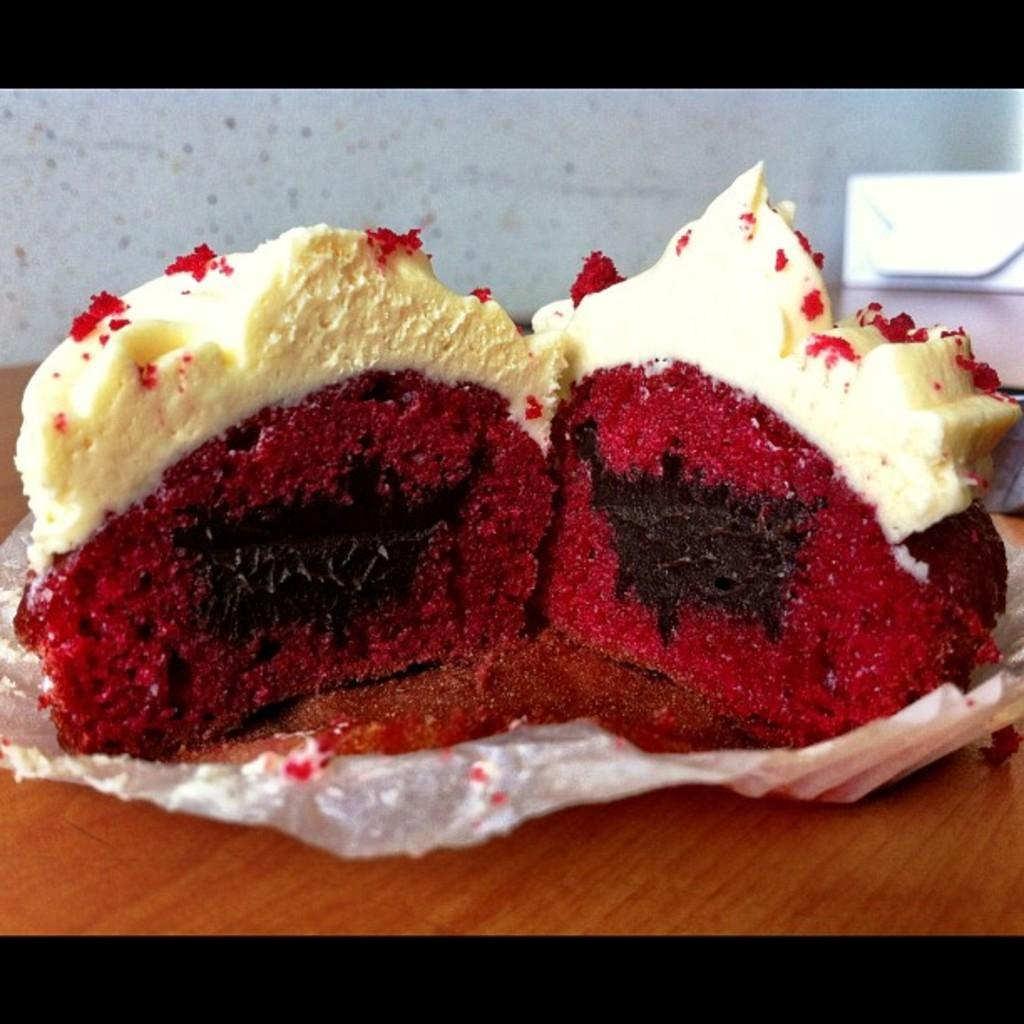What is the main object in the image? There is a table in the image. What is placed on the table? There is a paper on the table. What is on the paper? There are pieces of cake on the paper. How many women are visible in the image? There are no women present in the image. What type of clover can be seen growing on the table? There is no clover present in the image. 